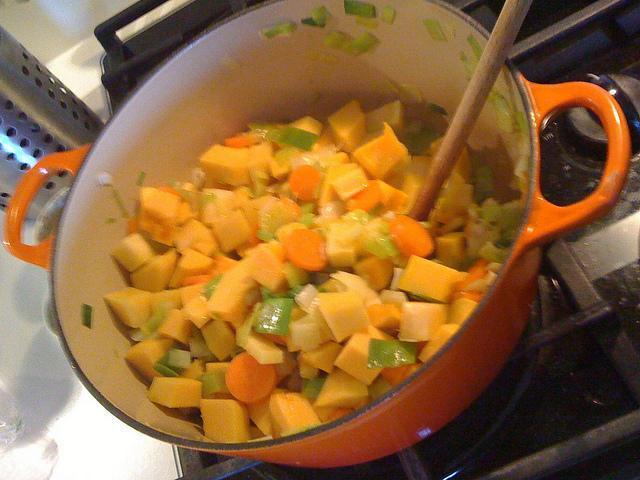How many spoons are there?
Give a very brief answer. 1. 